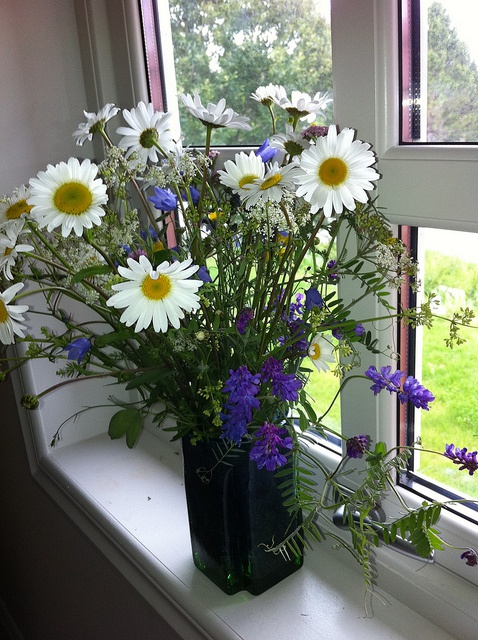Describe the objects in this image and their specific colors. I can see potted plant in gray, black, darkgray, and lightgray tones and vase in gray, black, darkgreen, and navy tones in this image. 